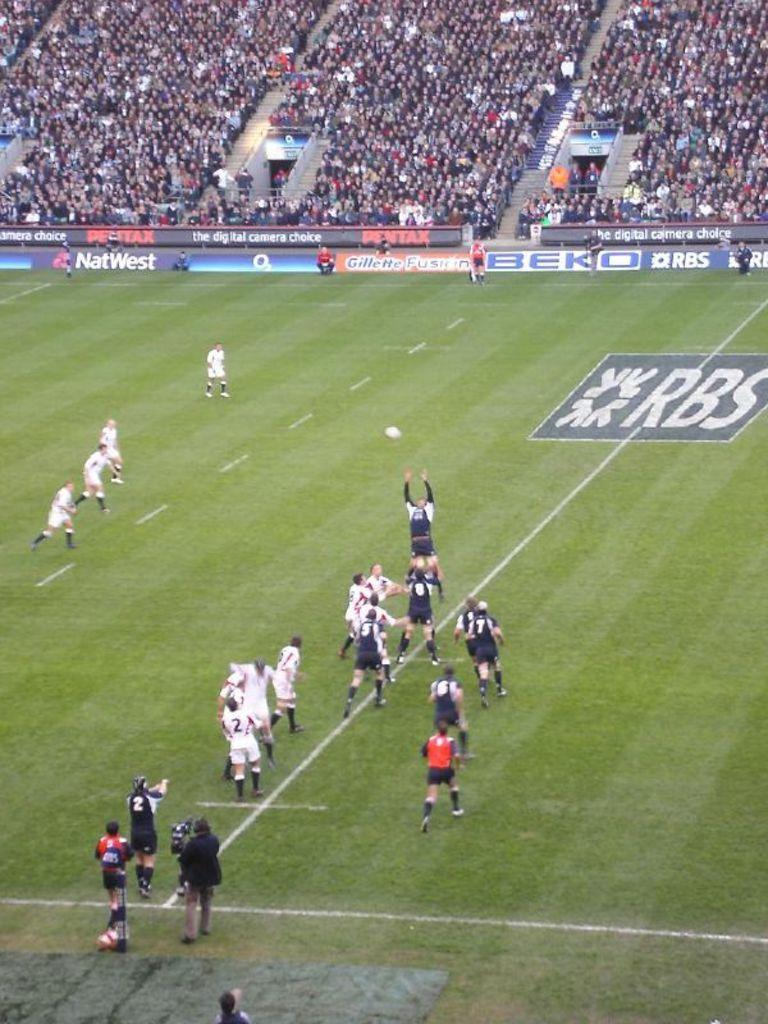<image>
Write a terse but informative summary of the picture. Players on a field where sponsor banners like NatWest hang in front of the crowd. 